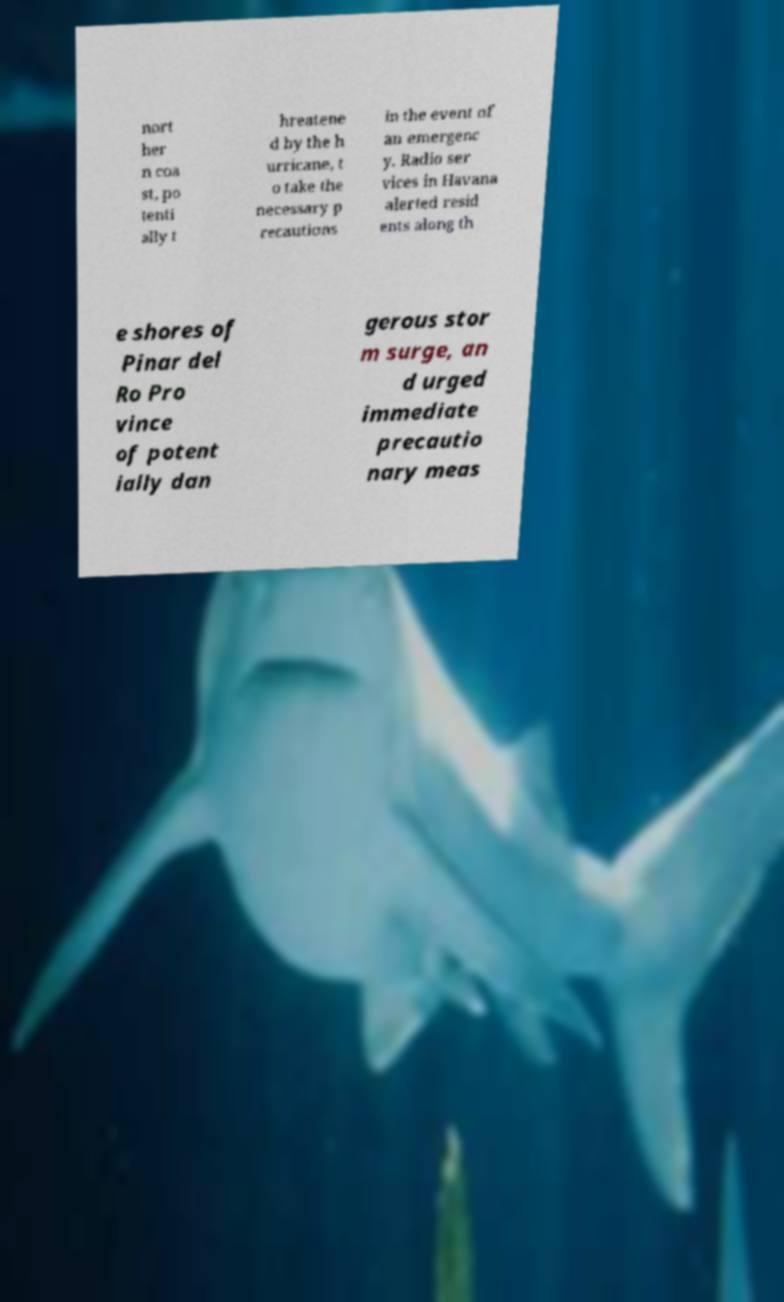For documentation purposes, I need the text within this image transcribed. Could you provide that? nort her n coa st, po tenti ally t hreatene d by the h urricane, t o take the necessary p recautions in the event of an emergenc y. Radio ser vices in Havana alerted resid ents along th e shores of Pinar del Ro Pro vince of potent ially dan gerous stor m surge, an d urged immediate precautio nary meas 